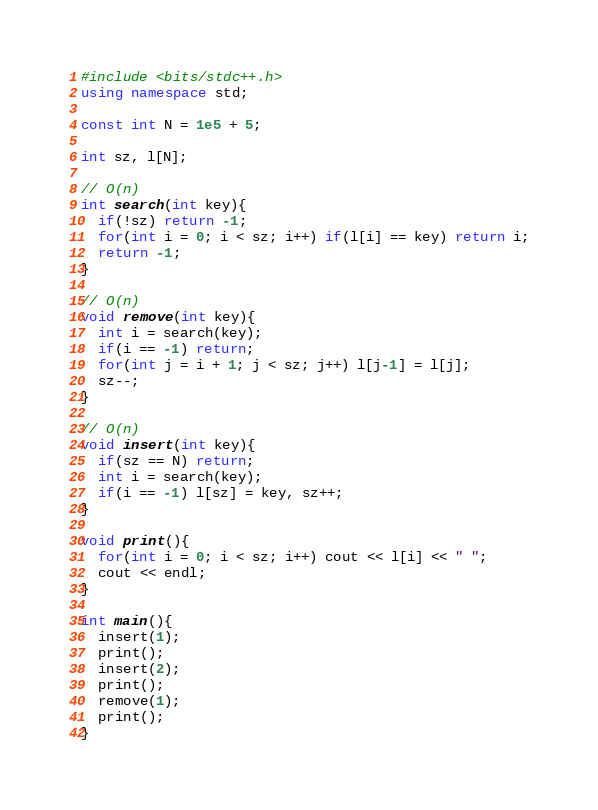Convert code to text. <code><loc_0><loc_0><loc_500><loc_500><_C++_>#include <bits/stdc++.h>
using namespace std;

const int N = 1e5 + 5;

int sz, l[N];

// O(n)
int search(int key){
  if(!sz) return -1;
  for(int i = 0; i < sz; i++) if(l[i] == key) return i;
  return -1;
}

// O(n)
void remove(int key){
  int i = search(key);
  if(i == -1) return;
  for(int j = i + 1; j < sz; j++) l[j-1] = l[j];
  sz--;
}

// O(n)
void insert(int key){
  if(sz == N) return;
  int i = search(key);
  if(i == -1) l[sz] = key, sz++;
}

void print(){
  for(int i = 0; i < sz; i++) cout << l[i] << " ";
  cout << endl;
}

int main(){
  insert(1);
  print();
  insert(2);
  print();
  remove(1);
  print();
}
</code> 